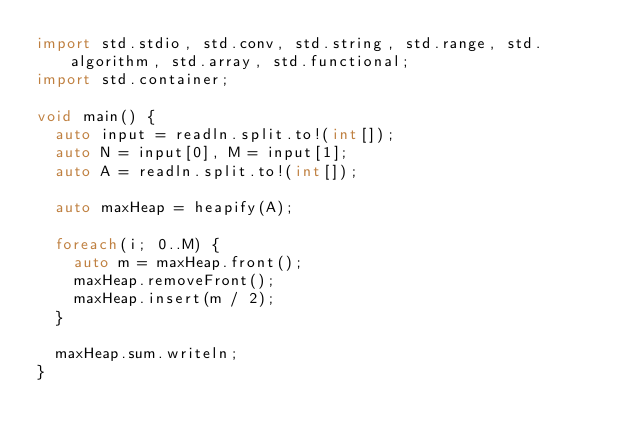<code> <loc_0><loc_0><loc_500><loc_500><_D_>import std.stdio, std.conv, std.string, std.range, std.algorithm, std.array, std.functional;
import std.container;

void main() {
  auto input = readln.split.to!(int[]);
  auto N = input[0], M = input[1];
  auto A = readln.split.to!(int[]);

  auto maxHeap = heapify(A);

  foreach(i; 0..M) {
    auto m = maxHeap.front();
    maxHeap.removeFront();
    maxHeap.insert(m / 2);
  }

  maxHeap.sum.writeln;
}</code> 